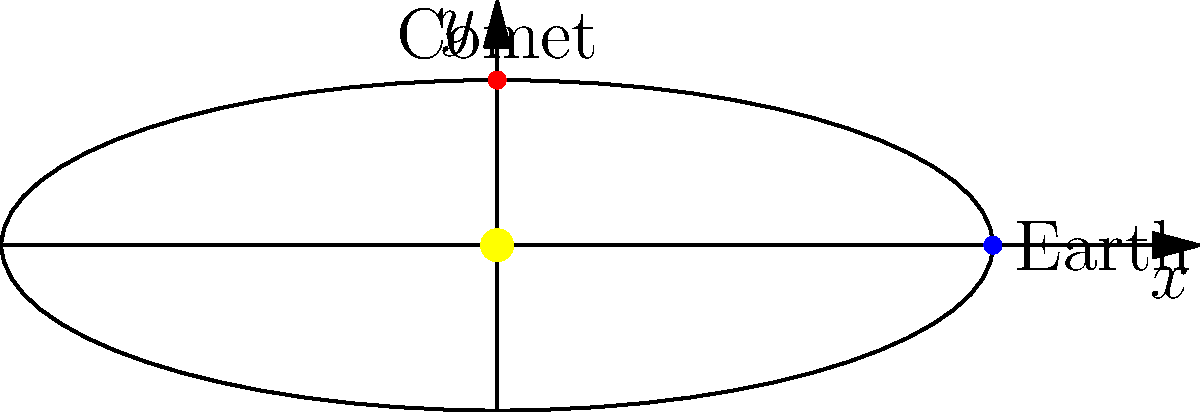Considering the orbital path of a comet around the Sun as shown in the diagram, why might this comet not be visible from Earth at certain times, despite its proximity to the Sun? To understand why a comet might not be visible from Earth at certain times, we need to consider several factors:

1. Orbital shape: Comets often have highly elliptical orbits, as shown in the diagram. This means they spend most of their time far from the Sun and Earth.

2. Earth's position: Earth's location in its own orbit affects our ability to see the comet. In the diagram, Earth is shown at one point, but it moves in its orbit around the Sun.

3. Comet's position: The comet's visibility depends on its position relative to both the Sun and Earth. In the diagram, the comet is shown at one point in its orbit.

4. Illumination: Comets are most visible when they are close to the Sun and their tails are developed due to solar radiation and solar wind. However, they must also be at a favorable angle relative to Earth for observation.

5. Size and composition: Some comets are naturally brighter than others due to their size and composition, affecting their visibility.

6. Solar glare: When a comet is too close to the Sun from Earth's perspective, the Sun's glare can make it difficult or impossible to see the comet.

7. Daytime vs. nighttime: Comets are generally only visible from Earth during nighttime hours when the sky is dark.

Given these factors, a comet might not be visible from Earth even when it's relatively close to the Sun because:
a) It could be on the opposite side of the Sun from Earth.
b) It might not be close enough to the Sun to develop a visible tail.
c) The angle between the Earth, Sun, and comet might not be favorable for observation.
d) The comet could be too small or dim to be seen from Earth's distance.
Answer: Position relative to Earth and Sun, illumination, and observational constraints 